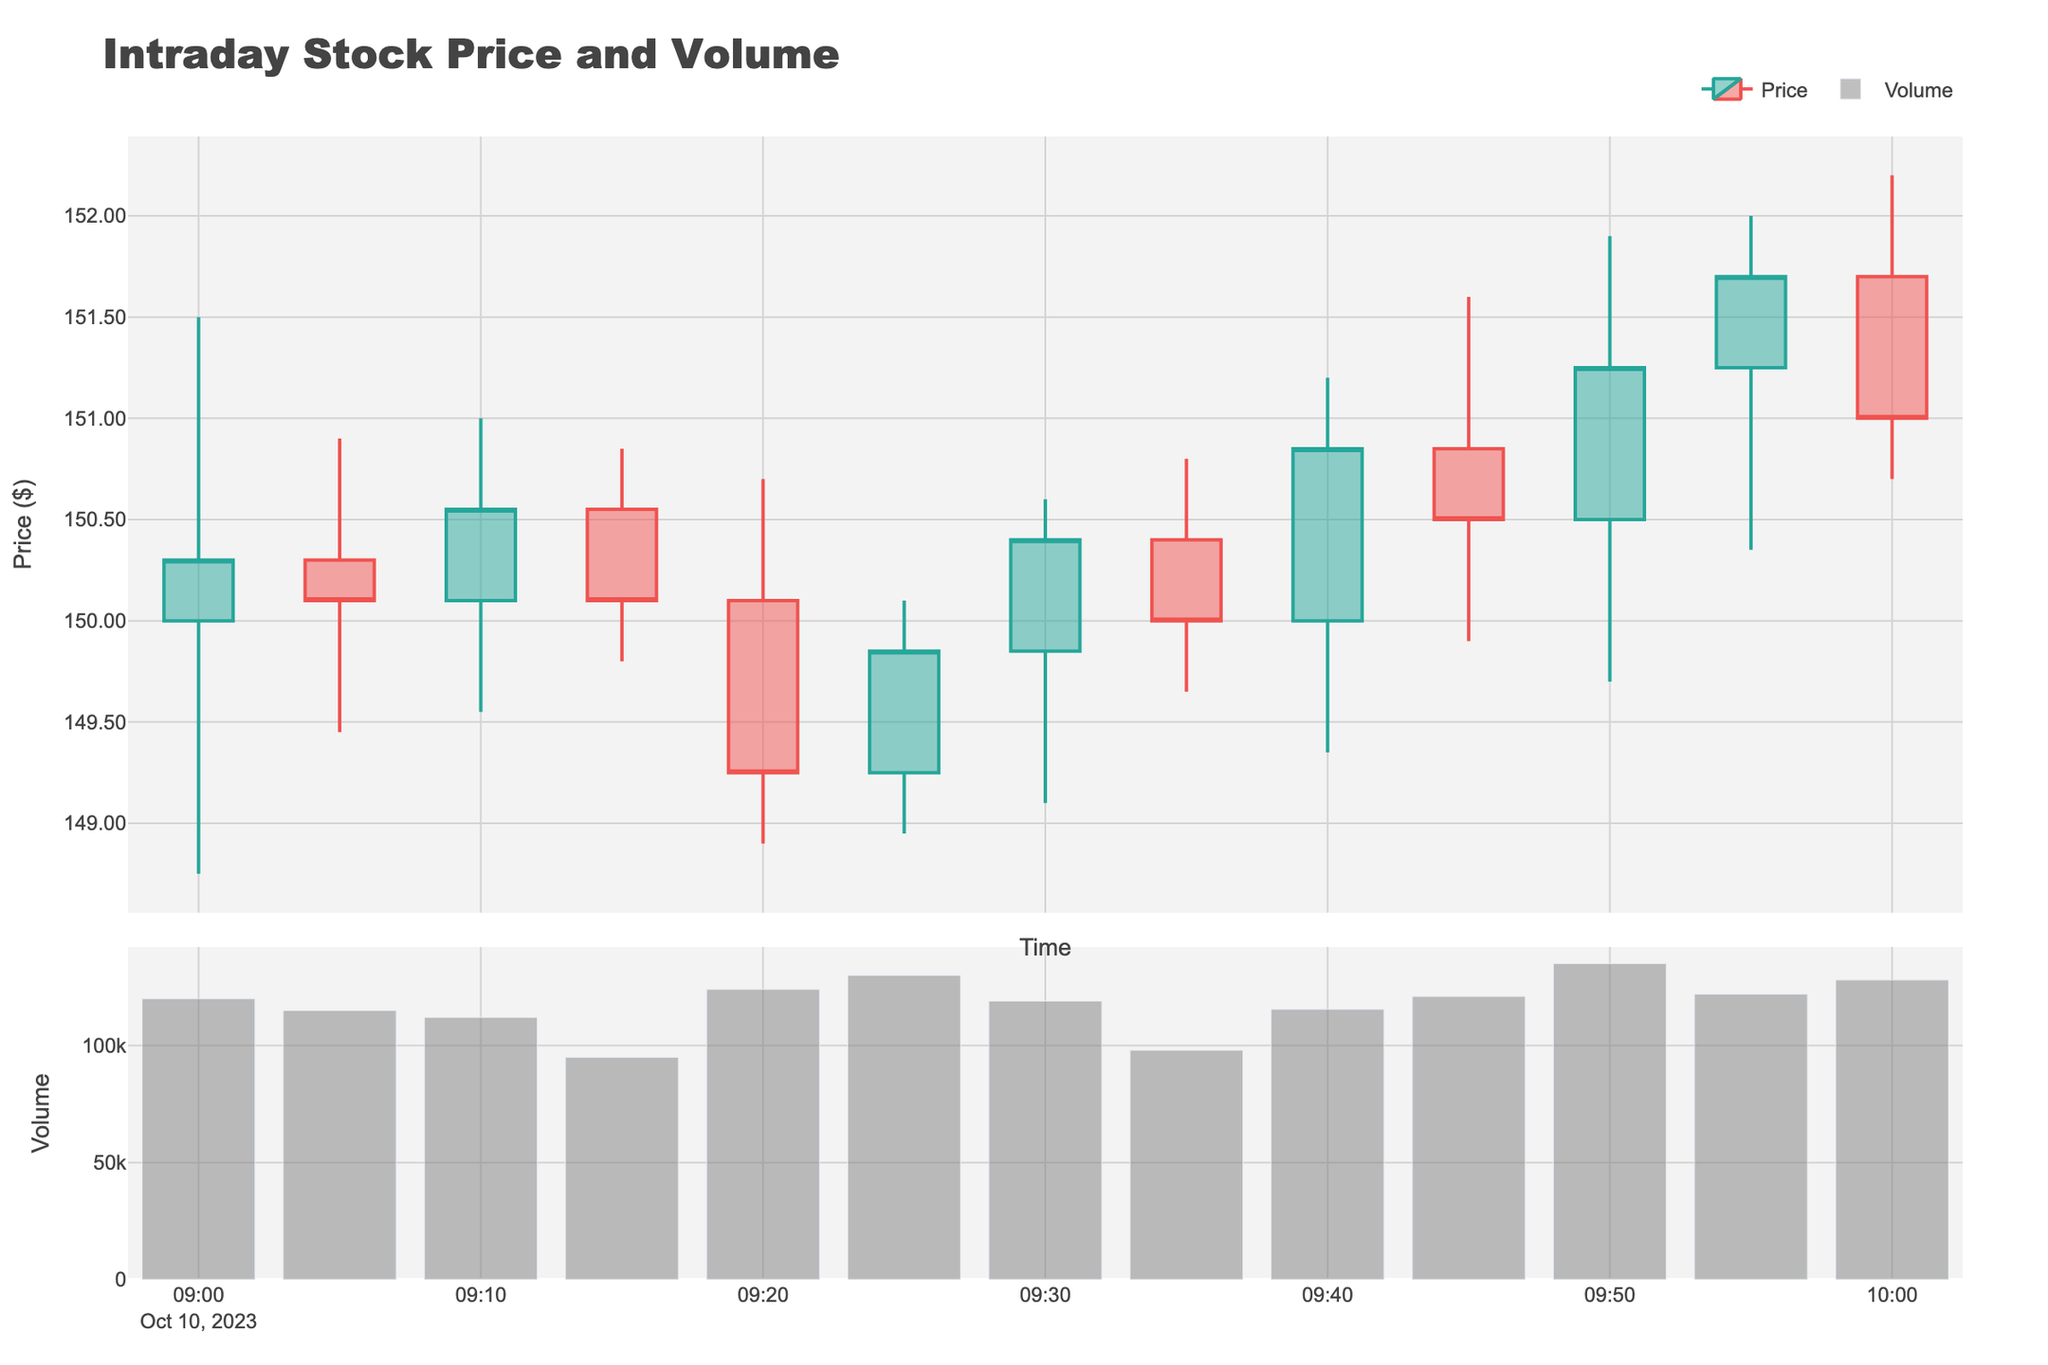What is the title of the plot? The title of the plot is displayed at the top, which reads "Intraday Stock Price and Volume".
Answer: Intraday Stock Price and Volume How many data points are shown in the candlestick plot? There are timestamps on the x-axis indicating different times, counting from 09:00:00 AM to 10:00:00 AM, resulting in 13 data points in total.
Answer: 13 Which time period shows the highest trading volume? On the volume bar chart in the second subplot, the highest bar corresponds to the timestamp 09:50:00 AM.
Answer: 09:50:00 AM What was the opening price at 09:00 AM? The opening price at 09:00 AM is seen in the first candlestick, which can be inferred from the specific open value given as $150.00.
Answer: $150.00 During which time period did the stock’s price close at its lowest value, and what was that value? Looking at the candlesticks, the lowest close value happens at 09:20:00 AM with a value of $149.25.
Answer: 09:20:00 AM, $149.25 What is the average of the closing prices for the first three data points? Summing the closing prices at 09:00:00, 09:05:00, and 09:10:00 gives $150.30, $150.10, and $150.55 respectively. The average is calculated as \((150.30 + 150.10 + 150.55)/3 = 150.32\).
Answer: $150.32 At which time period did the stock price have the largest range and what was the range? The range of a candlestick is determined by the difference between the high and low values. The largest range is observed at 09:50:00 AM where the range is \(151.90 - 149.70 = 2.20\).
Answer: 09:50:00 AM, $2.20 How did the stock price trend change between 09:25 AM and 09:35 AM? The price opened at $149.25 at 09:25 AM and closed at $150.40 at 09:30 AM, and then closed at $150.00 at 09:35 AM, showing fluctuation but an overall uptrend.
Answer: Uptrend Which time period shows both an increase in price and an increase in trading volume compared to the previous period? Comparing both price and volume for consecutive periods, at 09:40:00 AM, the price increased to $150.85 from $150.00, and the volume increased compared to 09:35:00 AM.
Answer: 09:40:00 AM Comparing the highest and lowest closing prices, what is the difference? The highest closing price is at 09:55:00 AM with $151.70, and the lowest at 09:20:00 AM with $149.25. The difference is \(151.70 - 149.25 = 2.45\).
Answer: $2.45 